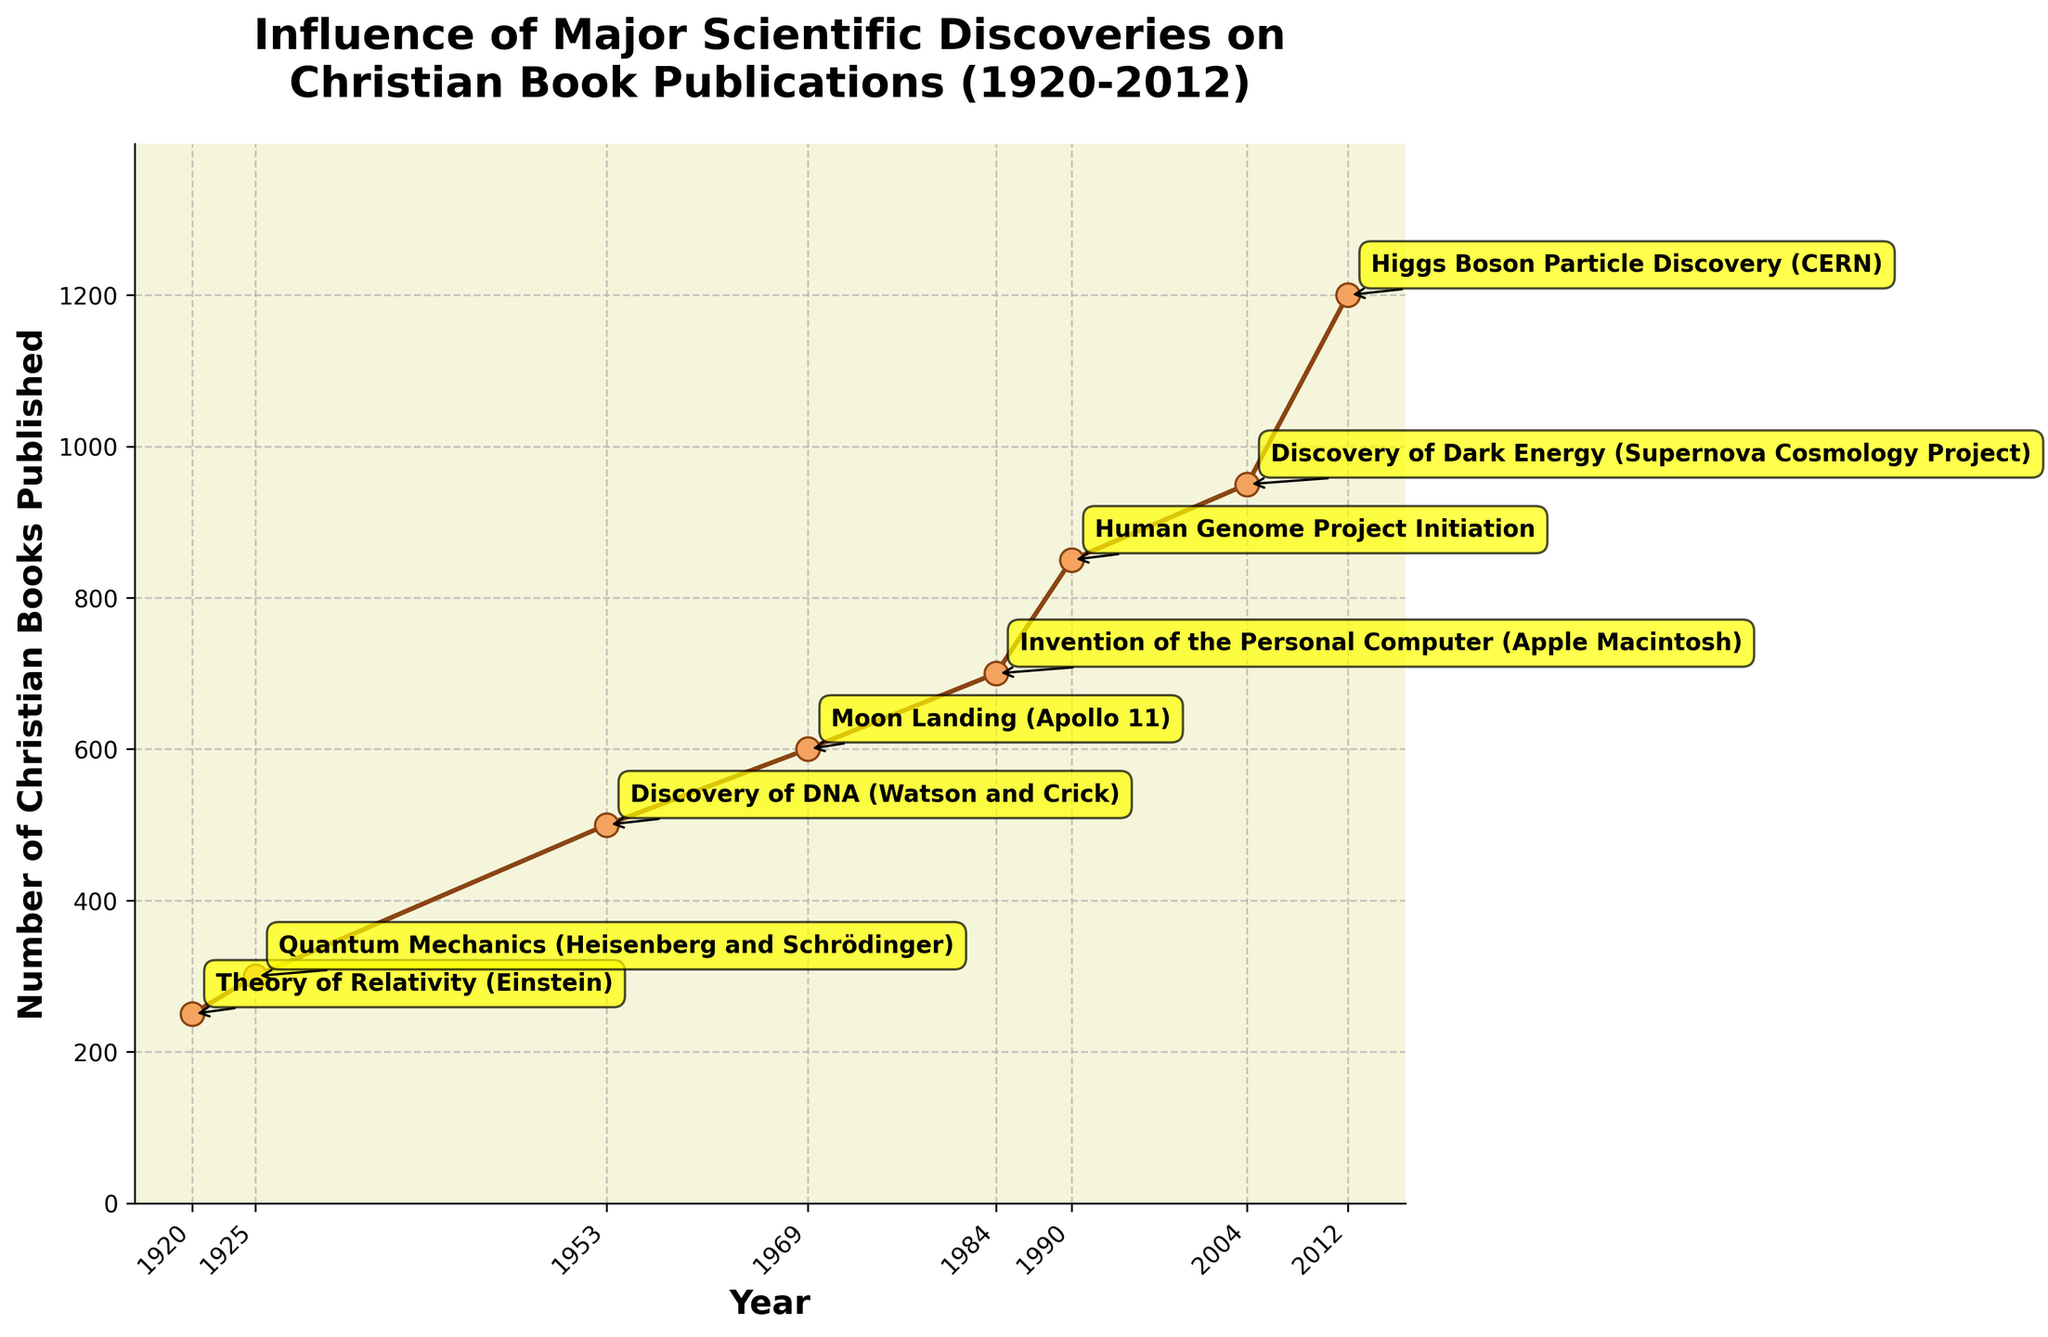How many years does the dataset cover? To find the number of years the dataset spans, locate the earliest and the latest years presented. From the figure, the years range from 1920 to 2012. Therefore, the dataset covers 2012 - 1920 = 92 years.
Answer: 92 Which scientific discovery is associated with the highest number of Christian books published? Identify the point on the graph where the number of Christian books published is highest, then check the annotation. The highest value on the graph is at 2012, which corresponds to the Higgs Boson Particle Discovery.
Answer: Higgs Boson Particle Discovery What is the difference in the number of Christian books published between the year 1920 and 1969? Find the number of books published in 1920 (250) and in 1969 (600). Subtract the former from the latter: 600 - 250 = 350.
Answer: 350 How did the number of Christian books published change from the initiation of the Human Genome Project to the discovery of Dark Energy? Note the points on the graph at 1990 (Human Genome Project Initiation, 850 books) and 2004 (Discovery of Dark Energy, 950 books), and calculate the difference: 950 - 850 = 100.
Answer: Increased by 100 What trend do you observe in the number of Christian books published in the periods before and after the Moon Landing in 1969? Compare the number of books published before 1969 (at 1953, 500 books) and after 1969 (at 1984, 700 books). There is a noticeable increase from 500 to 700 books.
Answer: Upward trend In which decade did the number of Christian books published show the most significant change? Look for the steepest slope on the plot between consecutive points. The most significant change is between 2004 (950) and 2012 (1200). Decade is 2004-2012.
Answer: 2000s How many discoveries in the dataset occurred before 1950, and how many after 1950? Count the number of points/annotations before 1950 and after 1950 based on the plot. Before 1950, there are 2: 1920 and 1925. After 1950, there are 6: 1953, 1969, 1984, 1990, 2004, and 2012.
Answer: 2 before 1950, 6 after 1950 What is the average number of Christian books published between 1953 and 1984? Identify the years 1953 (500 books), 1969 (600 books), and 1984 (700 books). Calculate the average: (500 + 600 + 700) / 3 = 600.
Answer: 600 What can you infer about the general trend in Christian book publications over the last century based on the plot? The plot shows a steady increase in the number of Christian books published over time, especially notable after significant scientific discoveries, indicating a positive correlation between major scientific discoveries and an increase in Christian book publications.
Answer: Increasing trend 